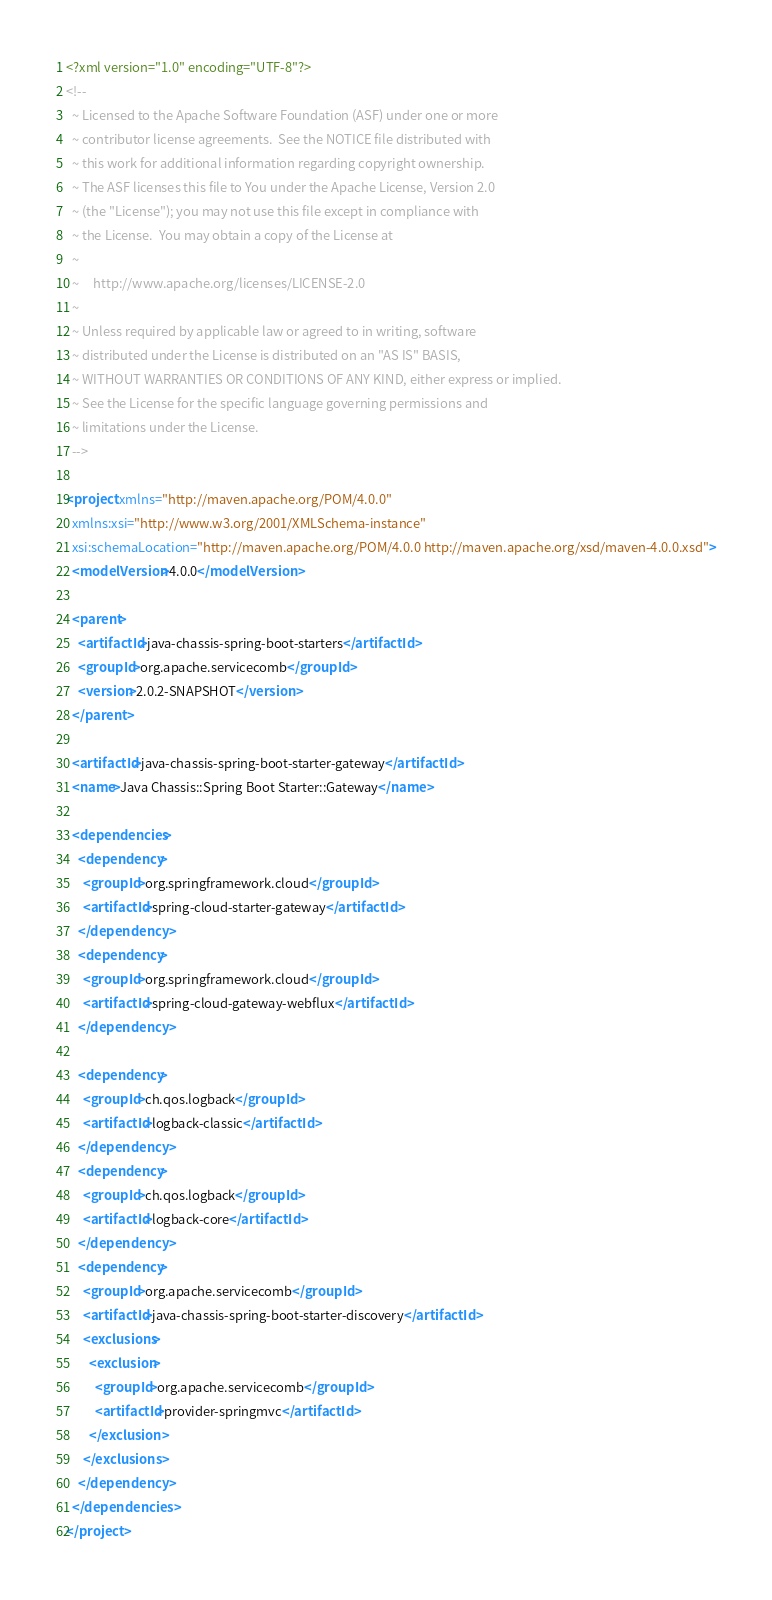<code> <loc_0><loc_0><loc_500><loc_500><_XML_><?xml version="1.0" encoding="UTF-8"?>
<!--
  ~ Licensed to the Apache Software Foundation (ASF) under one or more
  ~ contributor license agreements.  See the NOTICE file distributed with
  ~ this work for additional information regarding copyright ownership.
  ~ The ASF licenses this file to You under the Apache License, Version 2.0
  ~ (the "License"); you may not use this file except in compliance with
  ~ the License.  You may obtain a copy of the License at
  ~
  ~     http://www.apache.org/licenses/LICENSE-2.0
  ~
  ~ Unless required by applicable law or agreed to in writing, software
  ~ distributed under the License is distributed on an "AS IS" BASIS,
  ~ WITHOUT WARRANTIES OR CONDITIONS OF ANY KIND, either express or implied.
  ~ See the License for the specific language governing permissions and
  ~ limitations under the License.
  -->

<project xmlns="http://maven.apache.org/POM/4.0.0"
  xmlns:xsi="http://www.w3.org/2001/XMLSchema-instance"
  xsi:schemaLocation="http://maven.apache.org/POM/4.0.0 http://maven.apache.org/xsd/maven-4.0.0.xsd">
  <modelVersion>4.0.0</modelVersion>

  <parent>
    <artifactId>java-chassis-spring-boot-starters</artifactId>
    <groupId>org.apache.servicecomb</groupId>
    <version>2.0.2-SNAPSHOT</version>
  </parent>

  <artifactId>java-chassis-spring-boot-starter-gateway</artifactId>
  <name>Java Chassis::Spring Boot Starter::Gateway</name>

  <dependencies>
    <dependency>
      <groupId>org.springframework.cloud</groupId>
      <artifactId>spring-cloud-starter-gateway</artifactId>
    </dependency>
    <dependency>
      <groupId>org.springframework.cloud</groupId>
      <artifactId>spring-cloud-gateway-webflux</artifactId>
    </dependency>

    <dependency>
      <groupId>ch.qos.logback</groupId>
      <artifactId>logback-classic</artifactId>
    </dependency>
    <dependency>
      <groupId>ch.qos.logback</groupId>
      <artifactId>logback-core</artifactId>
    </dependency>
    <dependency>
      <groupId>org.apache.servicecomb</groupId>
      <artifactId>java-chassis-spring-boot-starter-discovery</artifactId>
      <exclusions>
        <exclusion>
          <groupId>org.apache.servicecomb</groupId>
          <artifactId>provider-springmvc</artifactId>
        </exclusion>
      </exclusions>
    </dependency>
  </dependencies>
</project></code> 